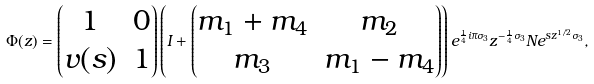Convert formula to latex. <formula><loc_0><loc_0><loc_500><loc_500>\Phi ( z ) = \begin{pmatrix} 1 & 0 \\ v ( s ) & 1 \end{pmatrix} \left ( I + \begin{pmatrix} m _ { 1 } + m _ { 4 } & m _ { 2 } \\ m _ { 3 } & m _ { 1 } - m _ { 4 } \end{pmatrix} \right ) e ^ { \frac { 1 } { 4 } i \pi \sigma _ { 3 } } z ^ { - \frac { 1 } { 4 } \sigma _ { 3 } } N e ^ { s z ^ { 1 / 2 } \sigma _ { 3 } } ,</formula> 